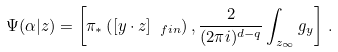<formula> <loc_0><loc_0><loc_500><loc_500>\Psi ( \alpha | z ) = \left [ \pi _ { \ast } \left ( [ y \cdot z ] _ { \ f i n } \right ) , \frac { 2 } { ( 2 \pi i ) ^ { d - q } } \int _ { z _ { \infty } } g _ { y } \right ] \, .</formula> 